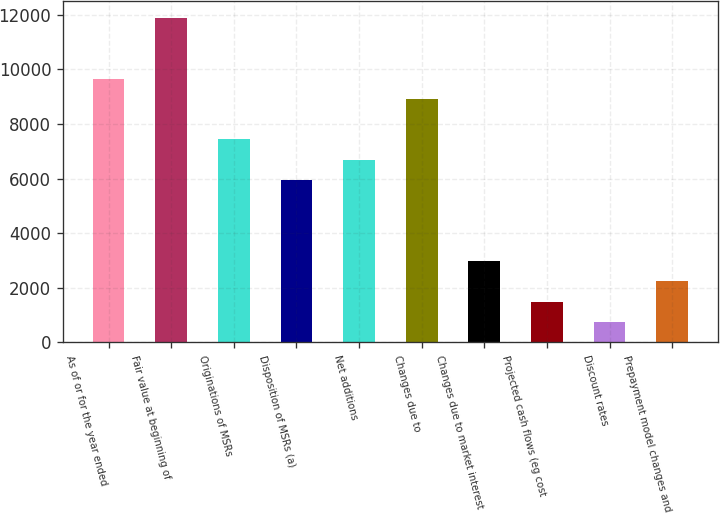Convert chart to OTSL. <chart><loc_0><loc_0><loc_500><loc_500><bar_chart><fcel>As of or for the year ended<fcel>Fair value at beginning of<fcel>Originations of MSRs<fcel>Disposition of MSRs (a)<fcel>Net additions<fcel>Changes due to<fcel>Changes due to market interest<fcel>Projected cash flows (eg cost<fcel>Discount rates<fcel>Prepayment model changes and<nl><fcel>9664.85<fcel>11893.7<fcel>7436<fcel>5950.1<fcel>6693.05<fcel>8921.9<fcel>2978.3<fcel>1492.4<fcel>749.45<fcel>2235.35<nl></chart> 